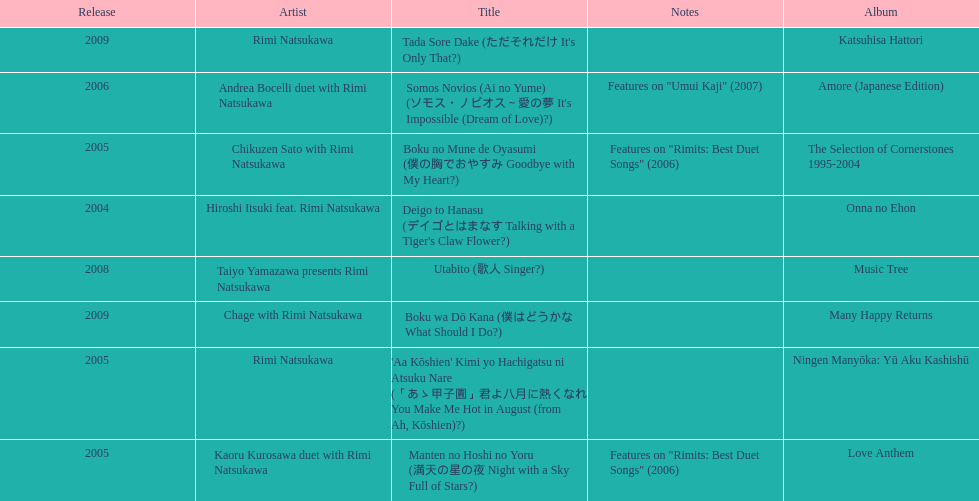What year was the first title released? 2004. 